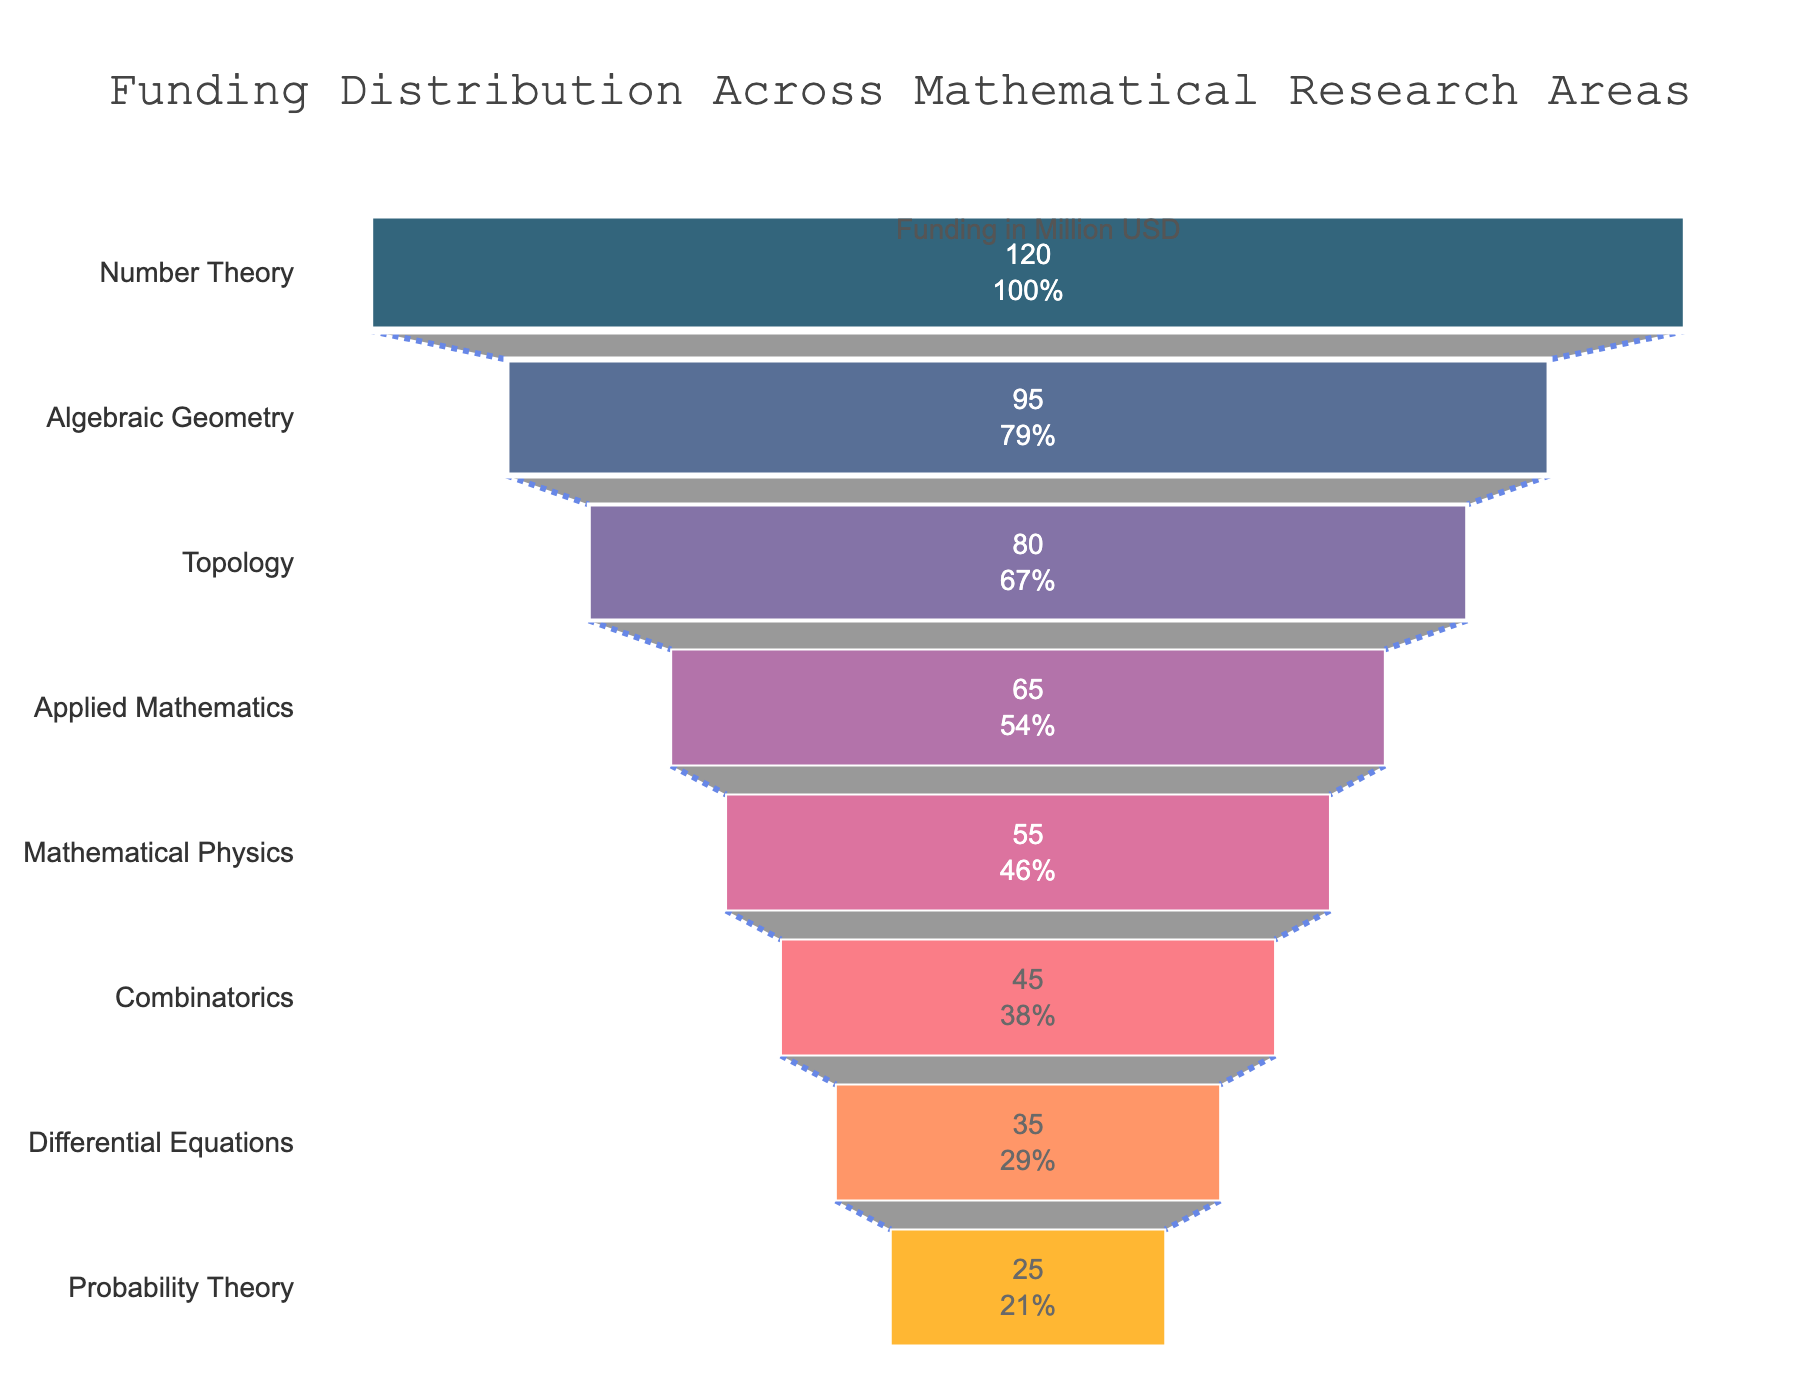what is the primary focus of this funnel chart? The title at the top of the funnel chart states "Funding Distribution Across Mathematical Research Areas", indicating that the primary focus of the chart is on how funding is distributed among various research areas in mathematics.
Answer: Funding Distribution Across Mathematical Research Areas what research area has the highest funding? The topmost segment of the funnel chart, which has the largest width, represents the area with the highest funding. According to the data, this is "Number Theory" with $120 million USD.
Answer: Number Theory how much funding does Algebraic Geometry receive? The label inside the funnel segment for "Algebraic Geometry" shows the funding amount. According to this data, Algebraic Geometry receives $95 million USD.
Answer: $95 million USD what is the combined funding of Topology and Probability Theory? Locate the segments for Topology and Probability Theory on the chart. According to the data, Topology receives $80 million USD and Probability Theory receives $25 million USD. Adding these together gives $80 million USD + $25 million USD = $105 million USD.
Answer: $105 million USD which research area receives the least funding, and how much is it? The bottommost segment of the funnel represents the area with the least funding, which is "Probability Theory" with $25 million USD.
Answer: Probability Theory, $25 million USD is the funding for Applied Mathematics higher than Differential Equations? To compare the funding, refer to their respective values. Applied Mathematics receives $65 million USD while Differential Equations receives $35 million USD, so Applied Mathematics has a higher funding.
Answer: Yes what percentage of the initial funding does Combinatorics represent? The value and percentage for each segment are inside the funnel chart. For Combinatorics, the information inside its segment will reveal that it represents a certain percentage of the total initial funding (which is from the top-most value). Given the data, Combinatorics represents approximately 14.3% of the initial funding of $120 million USD.
Answer: 14.3% by how much is the funding for Mathematical Physics greater than Probability Theory? According to the data, the funding for Mathematical Physics is $55 million USD and for Probability Theory is $25 million USD. The difference is $55 million USD - $25 million USD = $30 million USD.
Answer: $30 million USD which two research areas have a combined funding equal to that of Number Theory? Number Theory has $120 million USD in funding. Observing the data, Algebraic Geometry ($95 million USD) and Probability Theory ($25 million USD) combined would exactly match the $120 million USD of Number Theory.
Answer: Algebraic Geometry and Probability Theory 